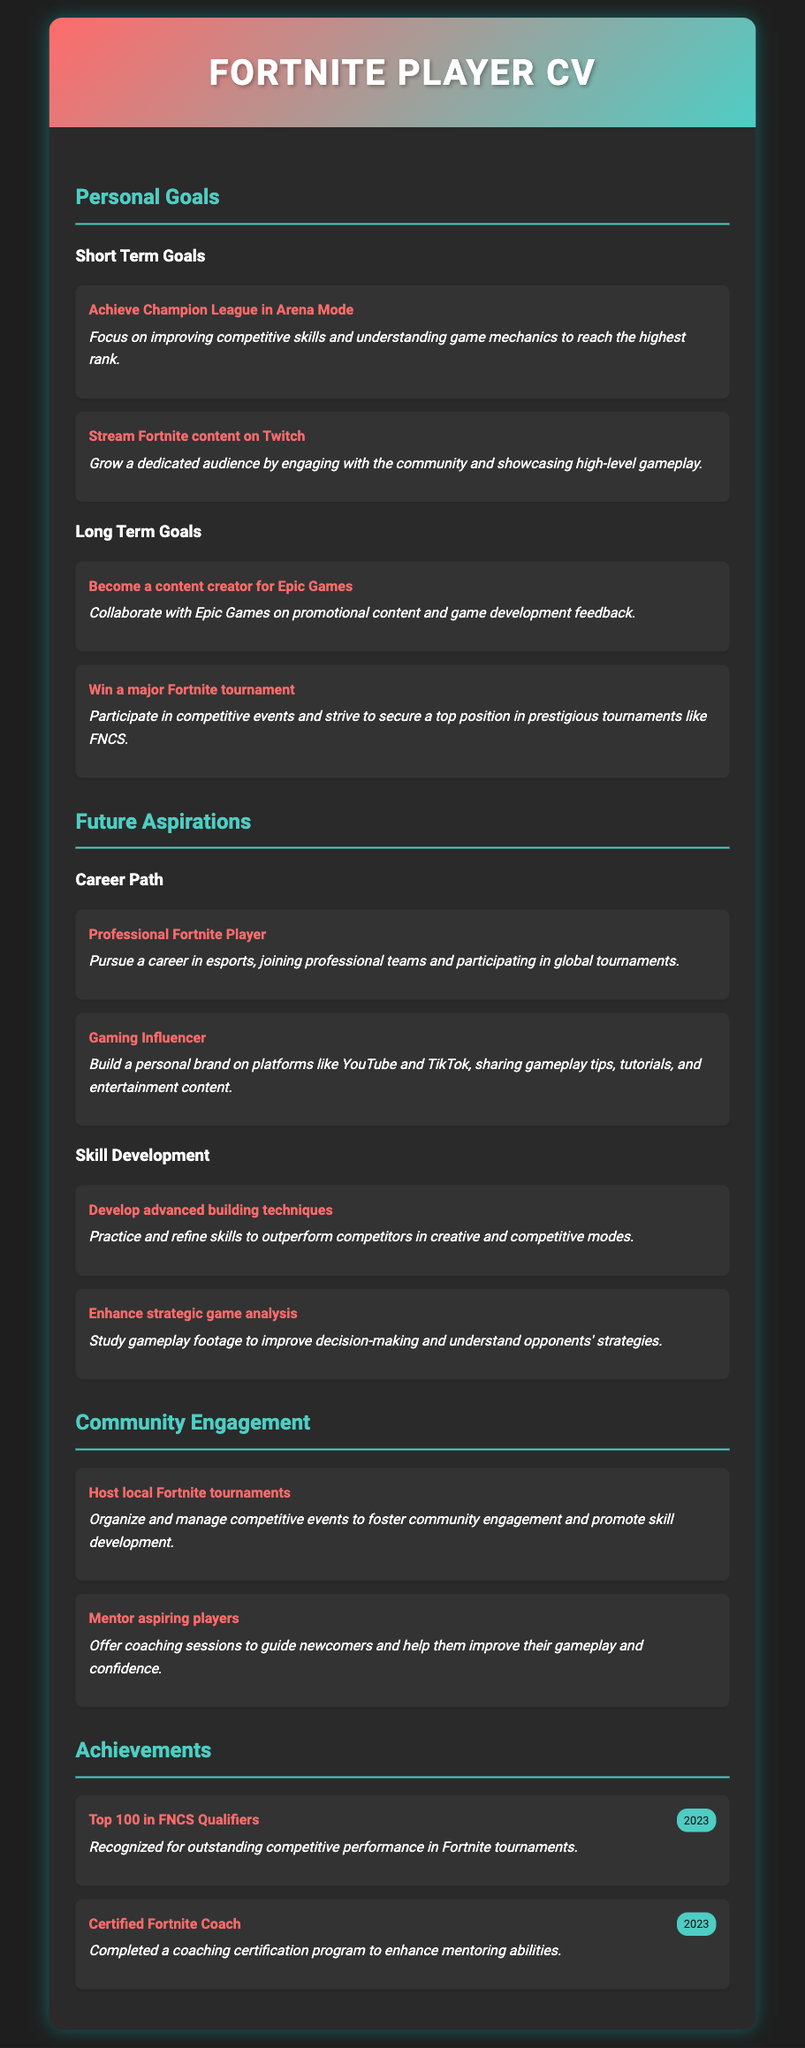What is the first short-term goal mentioned? The first short-term goal is listed under 'Short Term Goals' in the CV document.
Answer: Achieve Champion League in Arena Mode How many long-term goals are listed? The document lists a total of two long-term goals under the 'Long Term Goals' section.
Answer: 2 What type of player does the individual aspire to be? The aspiration to become a professional Fortnite player is stated in the 'Career Path' section.
Answer: Professional Fortnite Player Which platform is mentioned for streaming Fortnite content? The document specifies Twitch as the platform for streaming content in the 'Short Term Goals' section.
Answer: Twitch What achievement did the individual accomplish in 2023? The document mentions two achievements in 2023, of which one is highlighted regarding the FNCS Qualifiers.
Answer: Top 100 in FNCS Qualifiers 